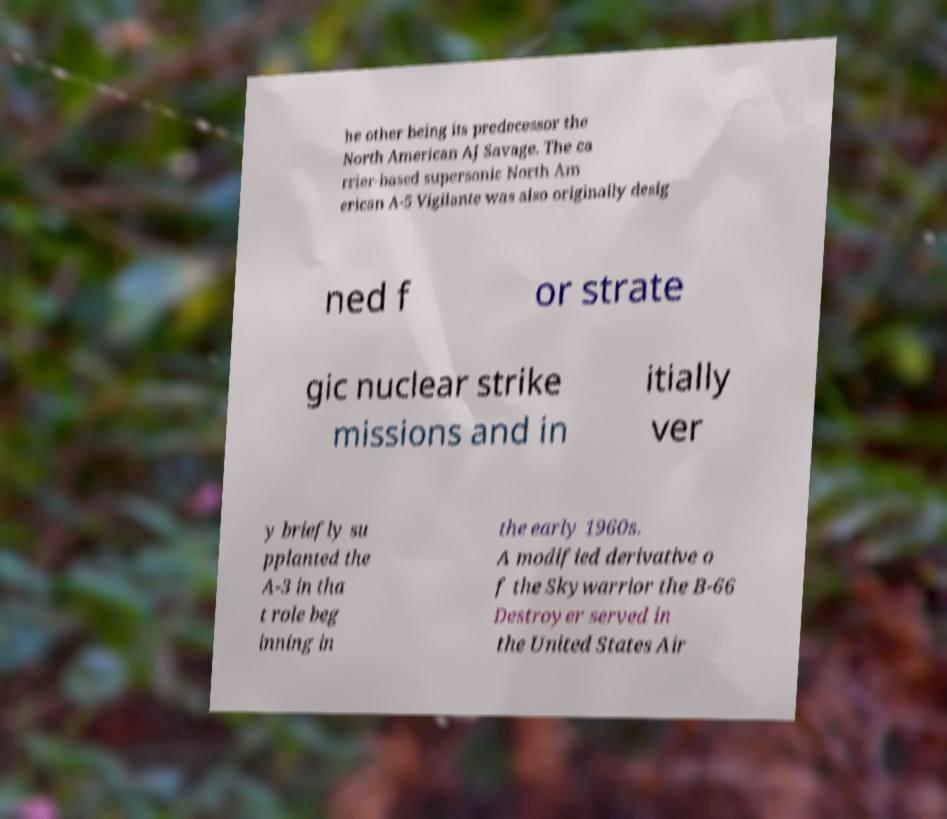Please identify and transcribe the text found in this image. he other being its predecessor the North American AJ Savage. The ca rrier-based supersonic North Am erican A-5 Vigilante was also originally desig ned f or strate gic nuclear strike missions and in itially ver y briefly su pplanted the A-3 in tha t role beg inning in the early 1960s. A modified derivative o f the Skywarrior the B-66 Destroyer served in the United States Air 